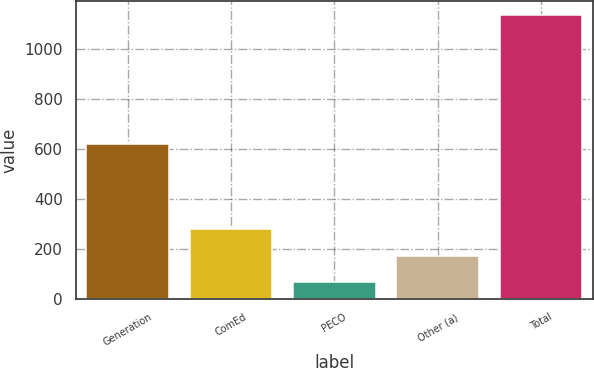<chart> <loc_0><loc_0><loc_500><loc_500><bar_chart><fcel>Generation<fcel>ComEd<fcel>PECO<fcel>Other (a)<fcel>Total<nl><fcel>622<fcel>280<fcel>66<fcel>173<fcel>1136<nl></chart> 